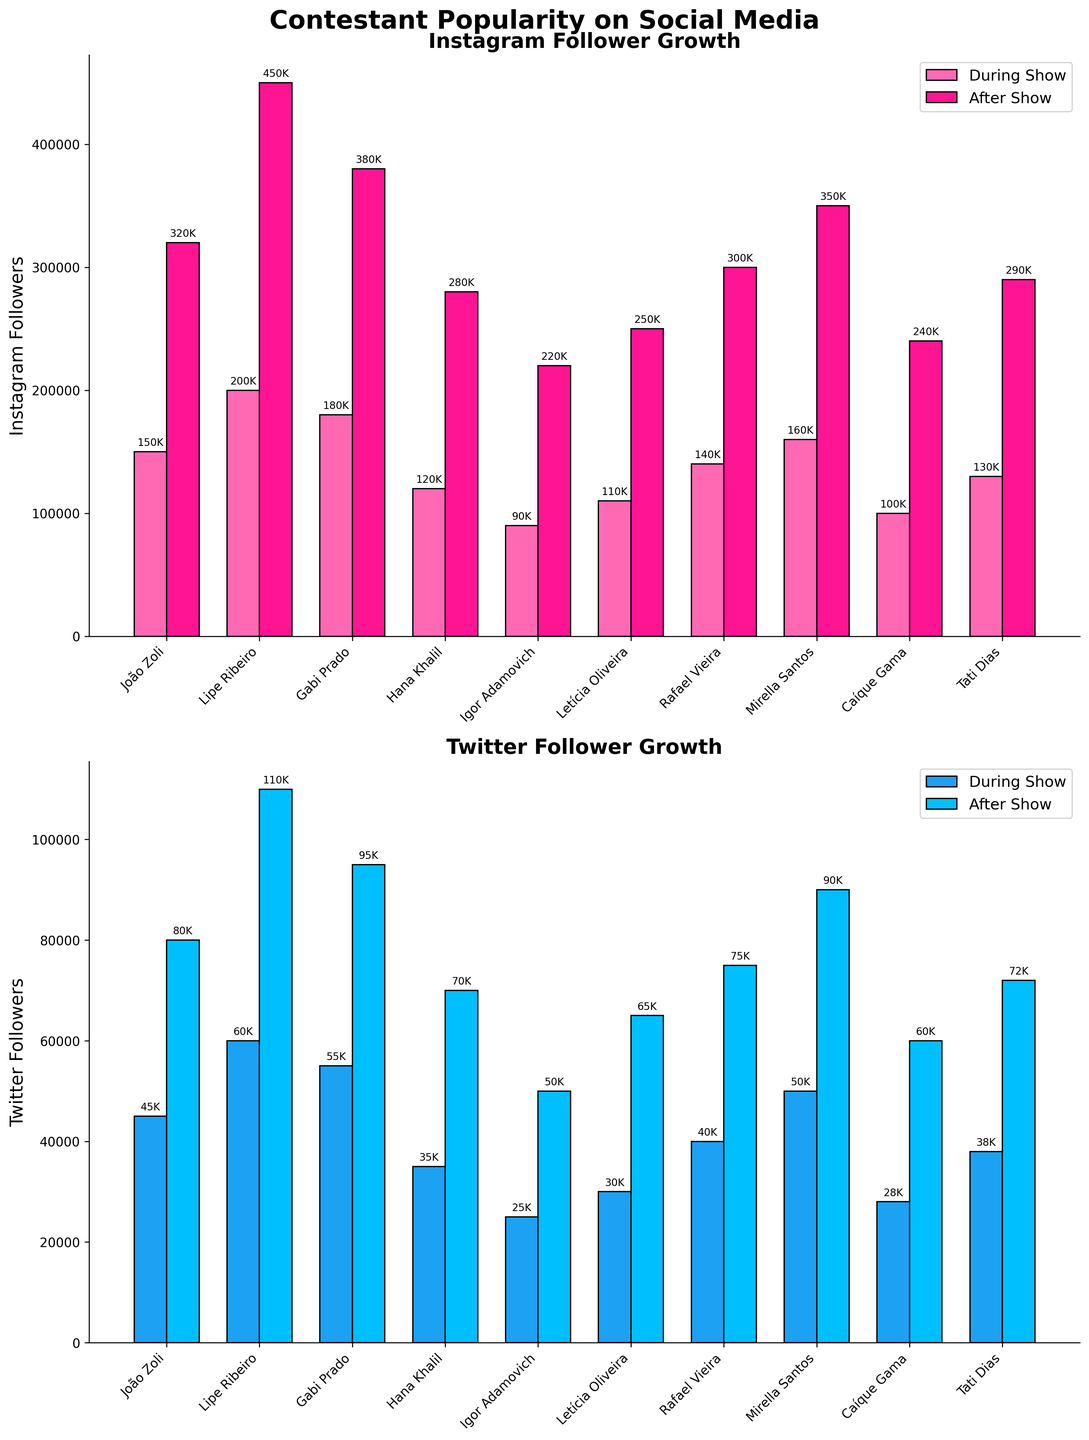What's the title of the Instagram followers subplot? The title of the Instagram followers subplot is found at the top of the first subplot. It states the subject of the bars in the first subplot.
Answer: Instagram Follower Growth How many contestants gained Twitter followers after the show ended? To find this, count the number of bars in the Twitter "After Show" section. There is one bar for each contestant.
Answer: 10 Which contestant had the highest increase in Instagram followers after the show? The highest bar in the Instagram "After Show" section indicates the contestant with the most followers gained. By comparing the heights of these bars, you can identify that contestant. For example, the bar for Lipe Ribeiro is the highest.
Answer: Lipe Ribeiro Compare the followers that João Zoli gained on Instagram and Twitter during the show. Which platform saw a greater increase? Looking at João Zoli's bars in the "During Show" section for both subplots, we compare the heights of the Instagram and Twitter bars. The Instagram followers bar is taller than the Twitter followers one.
Answer: Instagram What is the total number of Instagram followers gained by Hana Khalil during and after the show? Add the number of followers Hana Khalil gained during the show to the number gained after the show: 120,000 (during) + 280,000 (after).
Answer: 400,000 What is the average number of Twitter followers gained after the show for all contestants? Sum the Twitter "After Show" values for all contestants and then divide by the number of contestants, which is 10. The sum is 80000 + 110000 + 95000 + 70000 + 50000 + 65000 + 75000 + 90000 + 60000 + 72000 = 757,000. Therefore, the average is 757,000 / 10.
Answer: 75,700 Between Instagram and Twitter, on which platform did Caíque Gama gain more followers after the show? Compare the heights of Caíque Gama's bars in the Instagram and Twitter "After Show" sections. The Instagram bar is taller.
Answer: Instagram How much more Instagram followers did Mirella Santos gain after the show compared to during the show? Subtract the number of followers gained during the show from the number gained after the show: 350,000 (after) - 160,000 (during).
Answer: 190,000 Which contestant had the smallest increase in Twitter followers after the show? Find the shortest bar in the Twitter "After Show" section. This corresponds to the contestant who gained the least followers. Igor Adamovich's bar is the shortest.
Answer: Igor Adamovich 